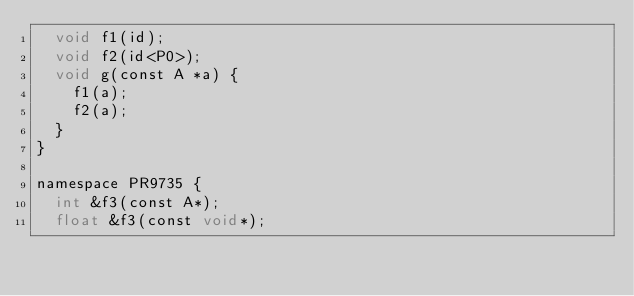<code> <loc_0><loc_0><loc_500><loc_500><_ObjectiveC_>  void f1(id);
  void f2(id<P0>);
  void g(const A *a) {
    f1(a);
    f2(a);
  }
}

namespace PR9735 {
  int &f3(const A*);
  float &f3(const void*);
</code> 